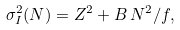<formula> <loc_0><loc_0><loc_500><loc_500>\sigma _ { I } ^ { 2 } ( N ) = Z ^ { 2 } + B \, N ^ { 2 } / f ,</formula> 